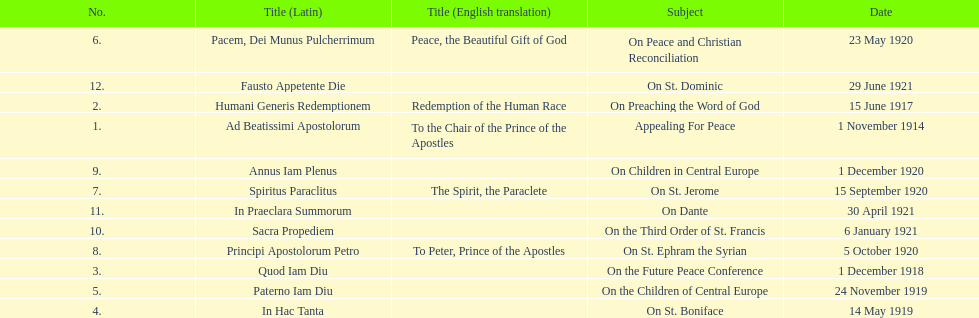What was the number of encyclopedias that had subjects relating specifically to children? 2. 